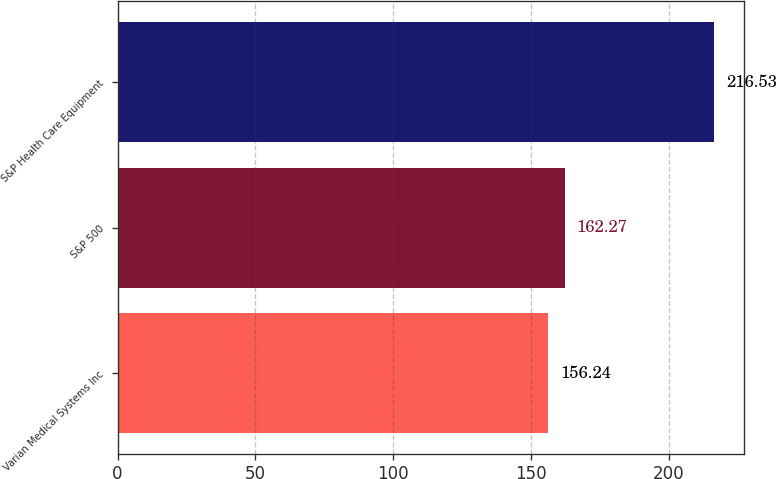<chart> <loc_0><loc_0><loc_500><loc_500><bar_chart><fcel>Varian Medical Systems Inc<fcel>S&P 500<fcel>S&P Health Care Equipment<nl><fcel>156.24<fcel>162.27<fcel>216.53<nl></chart> 